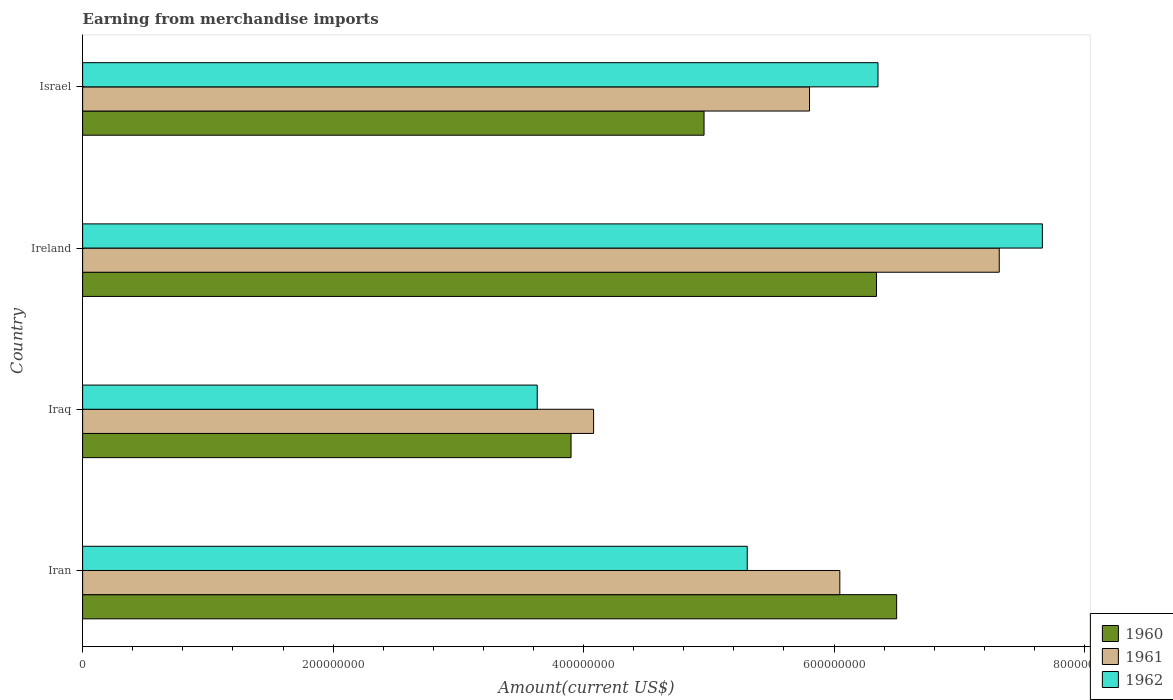How many different coloured bars are there?
Keep it short and to the point. 3. How many bars are there on the 1st tick from the top?
Keep it short and to the point. 3. How many bars are there on the 2nd tick from the bottom?
Keep it short and to the point. 3. What is the label of the 3rd group of bars from the top?
Provide a succinct answer. Iraq. What is the amount earned from merchandise imports in 1960 in Ireland?
Offer a terse response. 6.34e+08. Across all countries, what is the maximum amount earned from merchandise imports in 1960?
Provide a short and direct response. 6.50e+08. Across all countries, what is the minimum amount earned from merchandise imports in 1962?
Make the answer very short. 3.63e+08. In which country was the amount earned from merchandise imports in 1960 maximum?
Offer a terse response. Iran. In which country was the amount earned from merchandise imports in 1961 minimum?
Keep it short and to the point. Iraq. What is the total amount earned from merchandise imports in 1961 in the graph?
Provide a succinct answer. 2.32e+09. What is the difference between the amount earned from merchandise imports in 1962 in Iran and that in Iraq?
Provide a short and direct response. 1.68e+08. What is the difference between the amount earned from merchandise imports in 1961 in Iraq and the amount earned from merchandise imports in 1960 in Ireland?
Make the answer very short. -2.26e+08. What is the average amount earned from merchandise imports in 1960 per country?
Keep it short and to the point. 5.43e+08. What is the difference between the amount earned from merchandise imports in 1962 and amount earned from merchandise imports in 1961 in Israel?
Your response must be concise. 5.47e+07. In how many countries, is the amount earned from merchandise imports in 1961 greater than 280000000 US$?
Make the answer very short. 4. What is the ratio of the amount earned from merchandise imports in 1960 in Iran to that in Ireland?
Provide a succinct answer. 1.03. Is the amount earned from merchandise imports in 1961 in Iran less than that in Iraq?
Your answer should be very brief. No. Is the difference between the amount earned from merchandise imports in 1962 in Iraq and Israel greater than the difference between the amount earned from merchandise imports in 1961 in Iraq and Israel?
Keep it short and to the point. No. What is the difference between the highest and the second highest amount earned from merchandise imports in 1960?
Your answer should be very brief. 1.61e+07. What is the difference between the highest and the lowest amount earned from merchandise imports in 1962?
Keep it short and to the point. 4.03e+08. What does the 2nd bar from the bottom in Israel represents?
Make the answer very short. 1961. Is it the case that in every country, the sum of the amount earned from merchandise imports in 1960 and amount earned from merchandise imports in 1962 is greater than the amount earned from merchandise imports in 1961?
Provide a succinct answer. Yes. How many bars are there?
Keep it short and to the point. 12. Are all the bars in the graph horizontal?
Make the answer very short. Yes. How are the legend labels stacked?
Give a very brief answer. Vertical. What is the title of the graph?
Provide a short and direct response. Earning from merchandise imports. Does "1999" appear as one of the legend labels in the graph?
Provide a short and direct response. No. What is the label or title of the X-axis?
Your answer should be very brief. Amount(current US$). What is the Amount(current US$) in 1960 in Iran?
Provide a succinct answer. 6.50e+08. What is the Amount(current US$) in 1961 in Iran?
Your answer should be very brief. 6.05e+08. What is the Amount(current US$) of 1962 in Iran?
Your answer should be very brief. 5.31e+08. What is the Amount(current US$) in 1960 in Iraq?
Your response must be concise. 3.90e+08. What is the Amount(current US$) of 1961 in Iraq?
Your answer should be compact. 4.08e+08. What is the Amount(current US$) in 1962 in Iraq?
Your response must be concise. 3.63e+08. What is the Amount(current US$) in 1960 in Ireland?
Offer a very short reply. 6.34e+08. What is the Amount(current US$) in 1961 in Ireland?
Keep it short and to the point. 7.32e+08. What is the Amount(current US$) of 1962 in Ireland?
Make the answer very short. 7.66e+08. What is the Amount(current US$) of 1960 in Israel?
Provide a succinct answer. 4.96e+08. What is the Amount(current US$) in 1961 in Israel?
Your answer should be compact. 5.80e+08. What is the Amount(current US$) in 1962 in Israel?
Ensure brevity in your answer.  6.35e+08. Across all countries, what is the maximum Amount(current US$) in 1960?
Ensure brevity in your answer.  6.50e+08. Across all countries, what is the maximum Amount(current US$) in 1961?
Make the answer very short. 7.32e+08. Across all countries, what is the maximum Amount(current US$) in 1962?
Offer a terse response. 7.66e+08. Across all countries, what is the minimum Amount(current US$) in 1960?
Keep it short and to the point. 3.90e+08. Across all countries, what is the minimum Amount(current US$) in 1961?
Keep it short and to the point. 4.08e+08. Across all countries, what is the minimum Amount(current US$) of 1962?
Make the answer very short. 3.63e+08. What is the total Amount(current US$) in 1960 in the graph?
Your answer should be compact. 2.17e+09. What is the total Amount(current US$) in 1961 in the graph?
Provide a succinct answer. 2.32e+09. What is the total Amount(current US$) in 1962 in the graph?
Ensure brevity in your answer.  2.30e+09. What is the difference between the Amount(current US$) in 1960 in Iran and that in Iraq?
Ensure brevity in your answer.  2.60e+08. What is the difference between the Amount(current US$) of 1961 in Iran and that in Iraq?
Offer a very short reply. 1.97e+08. What is the difference between the Amount(current US$) in 1962 in Iran and that in Iraq?
Make the answer very short. 1.68e+08. What is the difference between the Amount(current US$) of 1960 in Iran and that in Ireland?
Ensure brevity in your answer.  1.61e+07. What is the difference between the Amount(current US$) of 1961 in Iran and that in Ireland?
Make the answer very short. -1.27e+08. What is the difference between the Amount(current US$) of 1962 in Iran and that in Ireland?
Your answer should be very brief. -2.36e+08. What is the difference between the Amount(current US$) of 1960 in Iran and that in Israel?
Keep it short and to the point. 1.54e+08. What is the difference between the Amount(current US$) of 1961 in Iran and that in Israel?
Your response must be concise. 2.42e+07. What is the difference between the Amount(current US$) of 1962 in Iran and that in Israel?
Make the answer very short. -1.04e+08. What is the difference between the Amount(current US$) in 1960 in Iraq and that in Ireland?
Keep it short and to the point. -2.44e+08. What is the difference between the Amount(current US$) in 1961 in Iraq and that in Ireland?
Offer a very short reply. -3.24e+08. What is the difference between the Amount(current US$) in 1962 in Iraq and that in Ireland?
Give a very brief answer. -4.03e+08. What is the difference between the Amount(current US$) in 1960 in Iraq and that in Israel?
Your answer should be very brief. -1.06e+08. What is the difference between the Amount(current US$) of 1961 in Iraq and that in Israel?
Make the answer very short. -1.72e+08. What is the difference between the Amount(current US$) of 1962 in Iraq and that in Israel?
Provide a short and direct response. -2.72e+08. What is the difference between the Amount(current US$) of 1960 in Ireland and that in Israel?
Keep it short and to the point. 1.38e+08. What is the difference between the Amount(current US$) of 1961 in Ireland and that in Israel?
Ensure brevity in your answer.  1.52e+08. What is the difference between the Amount(current US$) of 1962 in Ireland and that in Israel?
Keep it short and to the point. 1.31e+08. What is the difference between the Amount(current US$) in 1960 in Iran and the Amount(current US$) in 1961 in Iraq?
Keep it short and to the point. 2.42e+08. What is the difference between the Amount(current US$) of 1960 in Iran and the Amount(current US$) of 1962 in Iraq?
Your response must be concise. 2.87e+08. What is the difference between the Amount(current US$) in 1961 in Iran and the Amount(current US$) in 1962 in Iraq?
Your answer should be compact. 2.42e+08. What is the difference between the Amount(current US$) in 1960 in Iran and the Amount(current US$) in 1961 in Ireland?
Offer a terse response. -8.19e+07. What is the difference between the Amount(current US$) in 1960 in Iran and the Amount(current US$) in 1962 in Ireland?
Provide a succinct answer. -1.16e+08. What is the difference between the Amount(current US$) of 1961 in Iran and the Amount(current US$) of 1962 in Ireland?
Provide a short and direct response. -1.62e+08. What is the difference between the Amount(current US$) of 1960 in Iran and the Amount(current US$) of 1961 in Israel?
Your answer should be very brief. 6.96e+07. What is the difference between the Amount(current US$) in 1960 in Iran and the Amount(current US$) in 1962 in Israel?
Your response must be concise. 1.49e+07. What is the difference between the Amount(current US$) of 1961 in Iran and the Amount(current US$) of 1962 in Israel?
Ensure brevity in your answer.  -3.05e+07. What is the difference between the Amount(current US$) of 1960 in Iraq and the Amount(current US$) of 1961 in Ireland?
Give a very brief answer. -3.42e+08. What is the difference between the Amount(current US$) of 1960 in Iraq and the Amount(current US$) of 1962 in Ireland?
Keep it short and to the point. -3.76e+08. What is the difference between the Amount(current US$) in 1961 in Iraq and the Amount(current US$) in 1962 in Ireland?
Keep it short and to the point. -3.58e+08. What is the difference between the Amount(current US$) of 1960 in Iraq and the Amount(current US$) of 1961 in Israel?
Provide a short and direct response. -1.90e+08. What is the difference between the Amount(current US$) in 1960 in Iraq and the Amount(current US$) in 1962 in Israel?
Make the answer very short. -2.45e+08. What is the difference between the Amount(current US$) of 1961 in Iraq and the Amount(current US$) of 1962 in Israel?
Give a very brief answer. -2.27e+08. What is the difference between the Amount(current US$) of 1960 in Ireland and the Amount(current US$) of 1961 in Israel?
Provide a short and direct response. 5.35e+07. What is the difference between the Amount(current US$) of 1960 in Ireland and the Amount(current US$) of 1962 in Israel?
Ensure brevity in your answer.  -1.18e+06. What is the difference between the Amount(current US$) in 1961 in Ireland and the Amount(current US$) in 1962 in Israel?
Provide a succinct answer. 9.68e+07. What is the average Amount(current US$) of 1960 per country?
Make the answer very short. 5.43e+08. What is the average Amount(current US$) in 1961 per country?
Your answer should be very brief. 5.81e+08. What is the average Amount(current US$) in 1962 per country?
Provide a short and direct response. 5.74e+08. What is the difference between the Amount(current US$) in 1960 and Amount(current US$) in 1961 in Iran?
Offer a very short reply. 4.54e+07. What is the difference between the Amount(current US$) in 1960 and Amount(current US$) in 1962 in Iran?
Give a very brief answer. 1.19e+08. What is the difference between the Amount(current US$) in 1961 and Amount(current US$) in 1962 in Iran?
Ensure brevity in your answer.  7.39e+07. What is the difference between the Amount(current US$) of 1960 and Amount(current US$) of 1961 in Iraq?
Provide a succinct answer. -1.80e+07. What is the difference between the Amount(current US$) in 1960 and Amount(current US$) in 1962 in Iraq?
Make the answer very short. 2.70e+07. What is the difference between the Amount(current US$) of 1961 and Amount(current US$) of 1962 in Iraq?
Your answer should be compact. 4.50e+07. What is the difference between the Amount(current US$) in 1960 and Amount(current US$) in 1961 in Ireland?
Provide a short and direct response. -9.80e+07. What is the difference between the Amount(current US$) in 1960 and Amount(current US$) in 1962 in Ireland?
Make the answer very short. -1.32e+08. What is the difference between the Amount(current US$) in 1961 and Amount(current US$) in 1962 in Ireland?
Give a very brief answer. -3.44e+07. What is the difference between the Amount(current US$) of 1960 and Amount(current US$) of 1961 in Israel?
Your answer should be very brief. -8.42e+07. What is the difference between the Amount(current US$) in 1960 and Amount(current US$) in 1962 in Israel?
Offer a terse response. -1.39e+08. What is the difference between the Amount(current US$) in 1961 and Amount(current US$) in 1962 in Israel?
Provide a succinct answer. -5.47e+07. What is the ratio of the Amount(current US$) in 1960 in Iran to that in Iraq?
Your response must be concise. 1.67. What is the ratio of the Amount(current US$) in 1961 in Iran to that in Iraq?
Offer a very short reply. 1.48. What is the ratio of the Amount(current US$) of 1962 in Iran to that in Iraq?
Provide a succinct answer. 1.46. What is the ratio of the Amount(current US$) of 1960 in Iran to that in Ireland?
Provide a short and direct response. 1.03. What is the ratio of the Amount(current US$) of 1961 in Iran to that in Ireland?
Your answer should be compact. 0.83. What is the ratio of the Amount(current US$) of 1962 in Iran to that in Ireland?
Provide a short and direct response. 0.69. What is the ratio of the Amount(current US$) of 1960 in Iran to that in Israel?
Ensure brevity in your answer.  1.31. What is the ratio of the Amount(current US$) in 1961 in Iran to that in Israel?
Provide a short and direct response. 1.04. What is the ratio of the Amount(current US$) in 1962 in Iran to that in Israel?
Provide a succinct answer. 0.84. What is the ratio of the Amount(current US$) in 1960 in Iraq to that in Ireland?
Offer a very short reply. 0.62. What is the ratio of the Amount(current US$) in 1961 in Iraq to that in Ireland?
Offer a terse response. 0.56. What is the ratio of the Amount(current US$) in 1962 in Iraq to that in Ireland?
Your answer should be very brief. 0.47. What is the ratio of the Amount(current US$) of 1960 in Iraq to that in Israel?
Your response must be concise. 0.79. What is the ratio of the Amount(current US$) of 1961 in Iraq to that in Israel?
Provide a short and direct response. 0.7. What is the ratio of the Amount(current US$) of 1962 in Iraq to that in Israel?
Offer a very short reply. 0.57. What is the ratio of the Amount(current US$) in 1960 in Ireland to that in Israel?
Offer a terse response. 1.28. What is the ratio of the Amount(current US$) in 1961 in Ireland to that in Israel?
Keep it short and to the point. 1.26. What is the ratio of the Amount(current US$) in 1962 in Ireland to that in Israel?
Offer a terse response. 1.21. What is the difference between the highest and the second highest Amount(current US$) of 1960?
Offer a very short reply. 1.61e+07. What is the difference between the highest and the second highest Amount(current US$) in 1961?
Keep it short and to the point. 1.27e+08. What is the difference between the highest and the second highest Amount(current US$) in 1962?
Make the answer very short. 1.31e+08. What is the difference between the highest and the lowest Amount(current US$) of 1960?
Provide a succinct answer. 2.60e+08. What is the difference between the highest and the lowest Amount(current US$) in 1961?
Ensure brevity in your answer.  3.24e+08. What is the difference between the highest and the lowest Amount(current US$) in 1962?
Make the answer very short. 4.03e+08. 